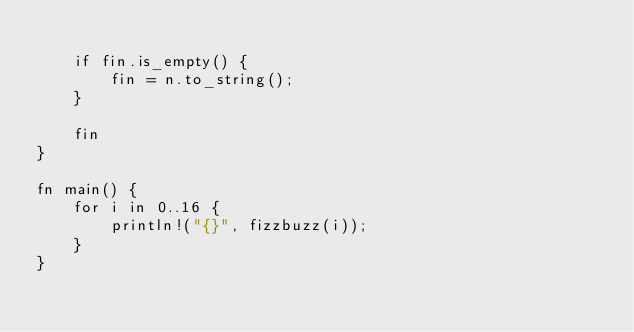Convert code to text. <code><loc_0><loc_0><loc_500><loc_500><_Rust_>
    if fin.is_empty() {
        fin = n.to_string();
    }

    fin
}

fn main() {
    for i in 0..16 {
        println!("{}", fizzbuzz(i));
    }
}
</code> 